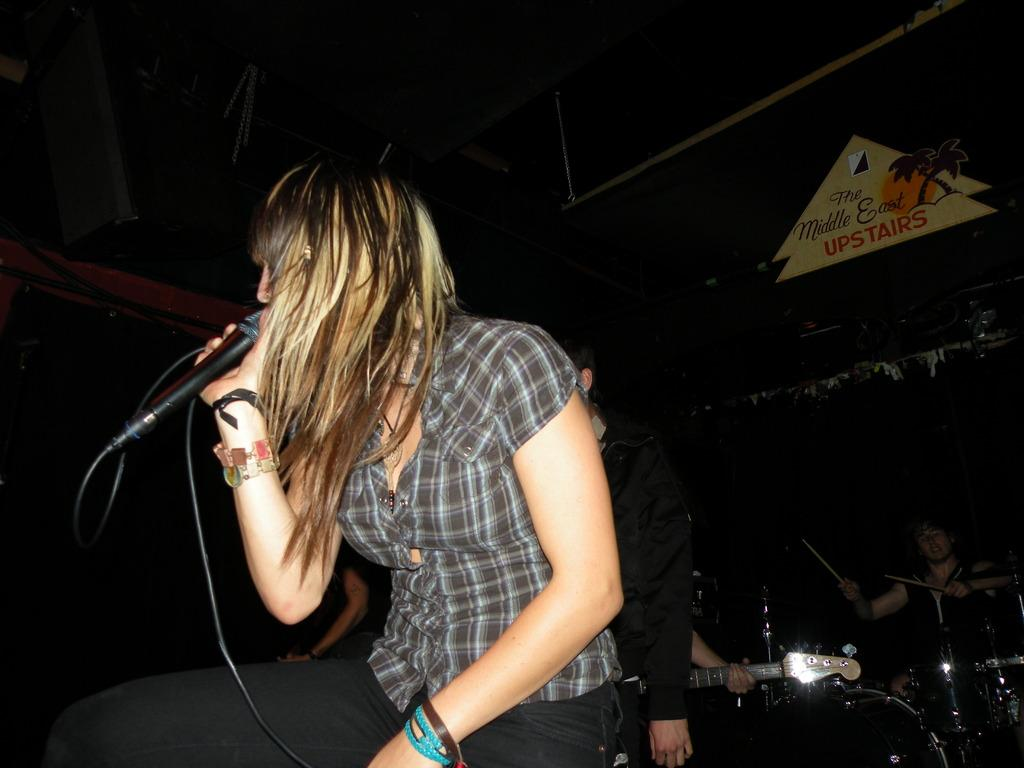Who is the main subject in the image? There is a woman in the image. What is the woman doing in the image? The woman is sitting and singing. What object is the woman holding in the image? The woman is holding a microphone. What other person can be seen in the image? There is a person playing musical drums in the image. What type of dinner is being served in the image? There is no dinner present in the image; it features a woman singing and holding a microphone, along with a person playing musical drums. Is there a ring visible on the woman's finger in the image? There is no mention of a ring in the provided facts, and no ring is visible in the image. 